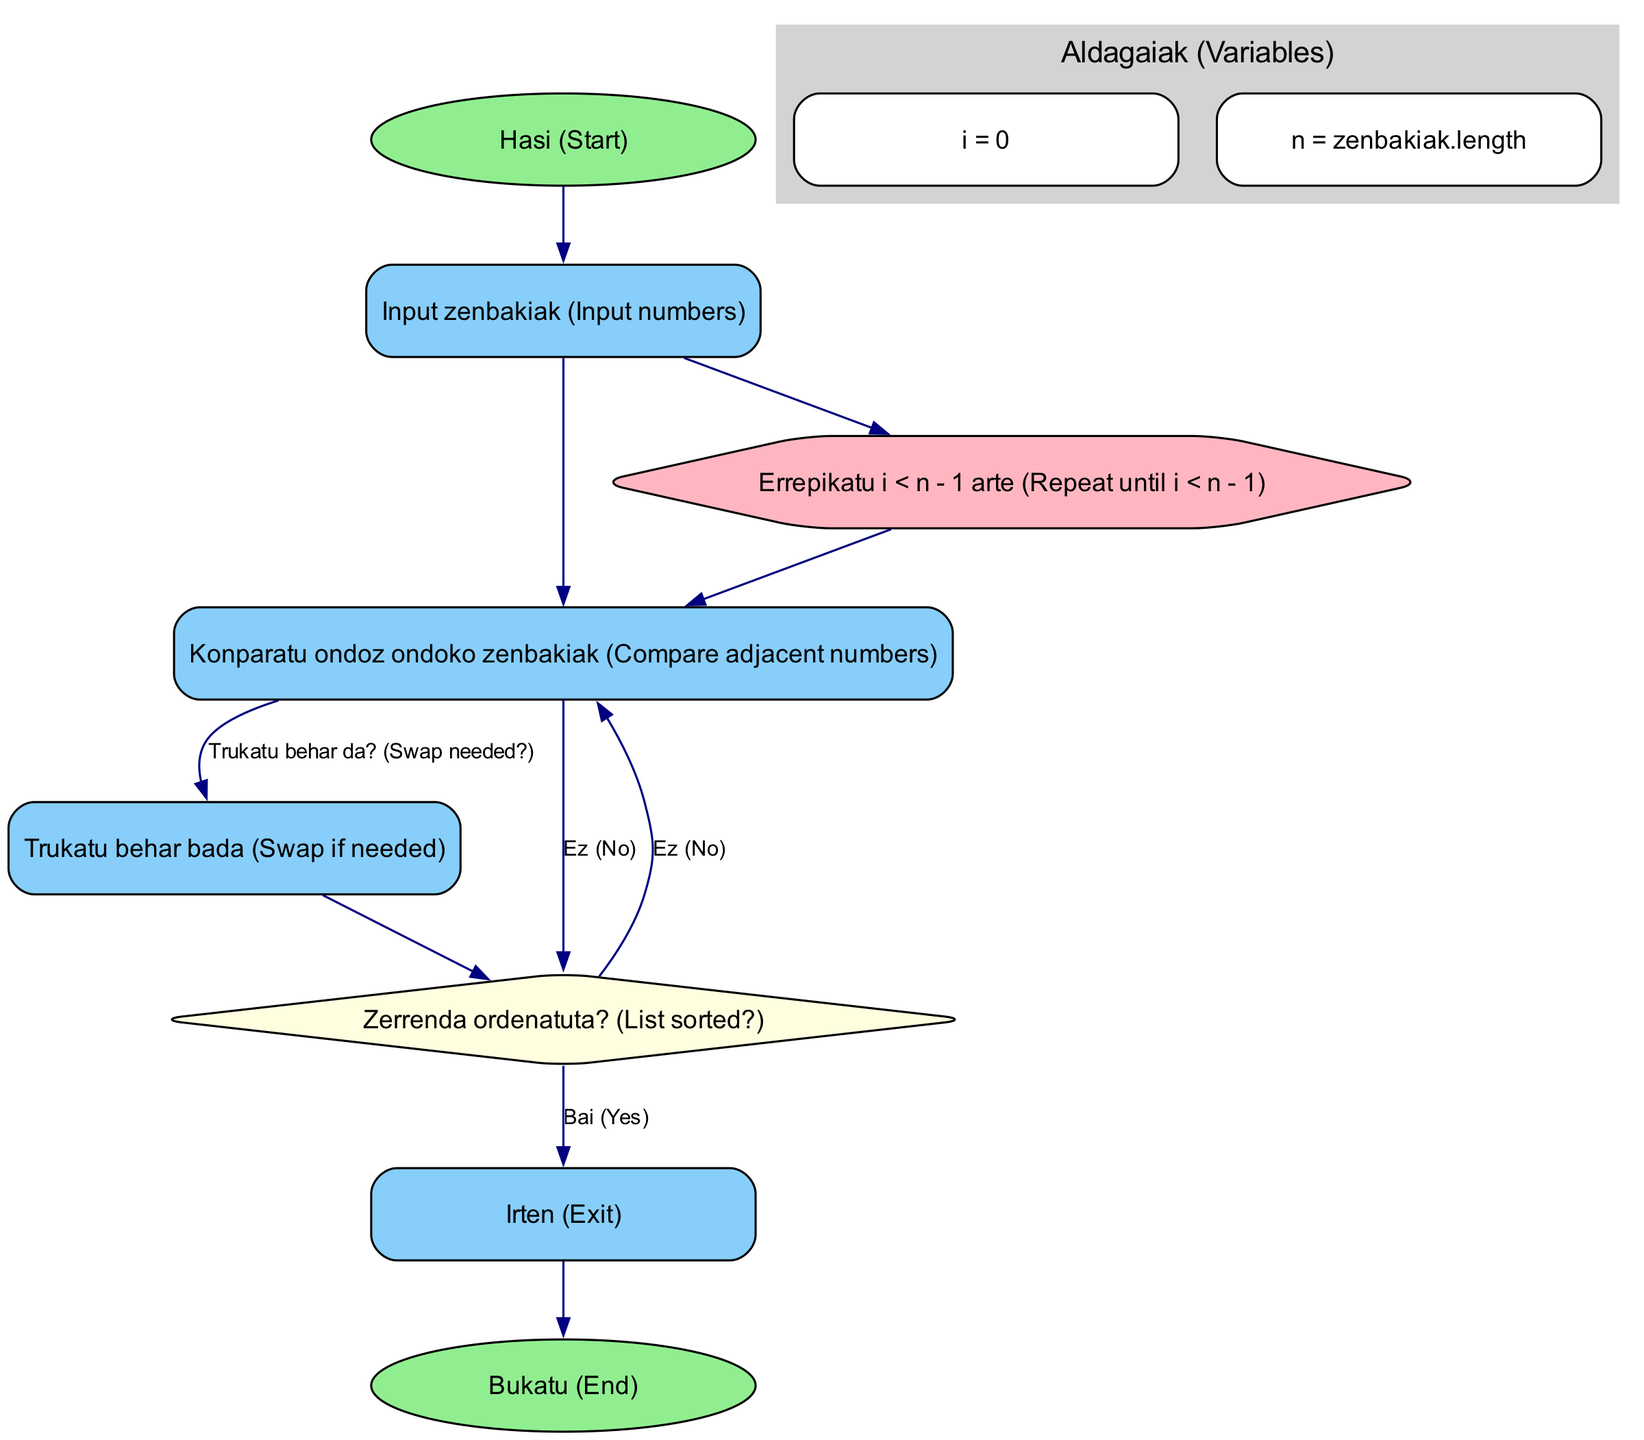What is the first node in the flowchart? The first node is labeled "Hasi (Start)," indicating the beginning of the algorithm process.
Answer: Hasi (Start) How many main action nodes are there in the diagram? There are four main action nodes: "Input zenbakiak," "Konparatu ondoz ondoko zenbakiak," "Trukatu behar bada," and "Zerrenda ordenatuta?" Thus, the total count is four.
Answer: 4 What is the decision represented by the diamond-shaped node? The diamond-shaped node is labeled "Zerrenda ordenatuta? (List sorted?),” which signifies a decision point in the algorithm where it checks if the list is sorted.
Answer: Zerrenda ordenatuta? (List sorted?) What happens if a swap is not needed? If a swap is not needed, the flowchart indicates to proceed directly to the "Zerrenda ordenatuta?" node without making any changes.
Answer: Proceed to Zerrenda ordenatuta? How does the algorithm handle the situation when the entire list has been checked? When the entire list has been checked, the algorithm directs the flow to the "Irten (Exit)" node, indicating the end of the sorting process.
Answer: Irten (Exit) What variable tracks the index during the sorting process? The variable that tracks the index during the sorting process is "i." This variable helps in iterating through the list of numbers being sorted.
Answer: i What color is used for the start and end nodes? The start and end nodes are both colored light green, designating them as the entry and exit points of the flowchart.
Answer: Light green How does the flowchart represent the repetition of the sorting process? The flowchart illustrates the repetition of the sorting process with a hexagon labeled "Errepikatu i < n - 1 arte," which indicates that the process will continue until the condition i < n - 1 is met.
Answer: Errepikatu i < n - 1 arte What is the label used for the input numbers node? The node for inputting numbers is labeled "Input zenbakiak," which identifies the action of taking the numbers to be sorted.
Answer: Input zenbakiak 